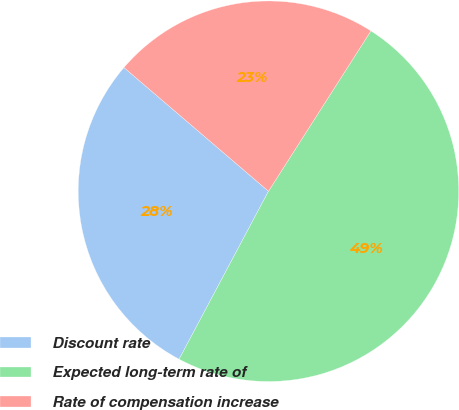Convert chart. <chart><loc_0><loc_0><loc_500><loc_500><pie_chart><fcel>Discount rate<fcel>Expected long-term rate of<fcel>Rate of compensation increase<nl><fcel>28.48%<fcel>48.73%<fcel>22.78%<nl></chart> 